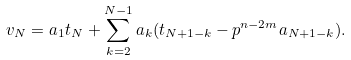<formula> <loc_0><loc_0><loc_500><loc_500>v _ { N } = a _ { 1 } t _ { N } + \sum _ { k = 2 } ^ { N - 1 } a _ { k } ( t _ { N + 1 - k } - p ^ { n - 2 m } a _ { N + 1 - k } ) .</formula> 